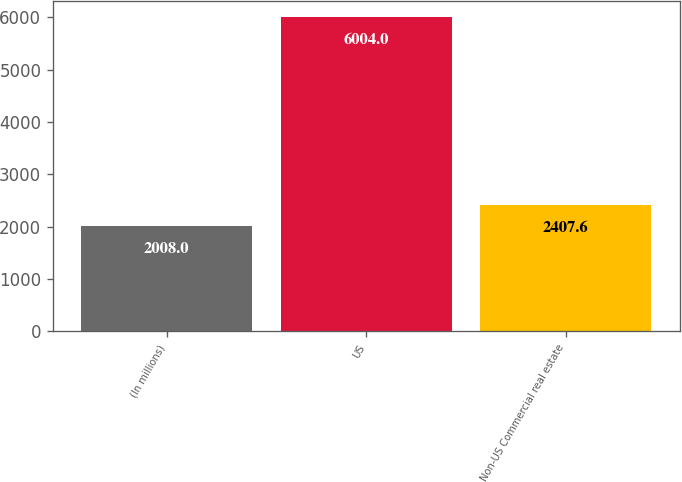Convert chart to OTSL. <chart><loc_0><loc_0><loc_500><loc_500><bar_chart><fcel>(In millions)<fcel>US<fcel>Non-US Commercial real estate<nl><fcel>2008<fcel>6004<fcel>2407.6<nl></chart> 